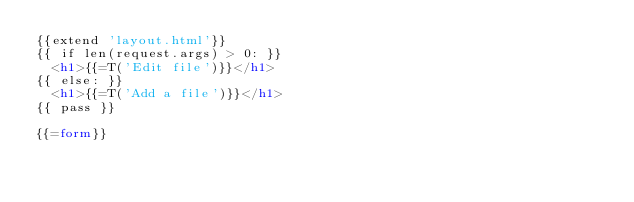<code> <loc_0><loc_0><loc_500><loc_500><_HTML_>{{extend 'layout.html'}}
{{ if len(request.args) > 0: }}
	<h1>{{=T('Edit file')}}</h1>
{{ else: }}
	<h1>{{=T('Add a file')}}</h1>
{{ pass }}

{{=form}}
</code> 